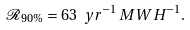Convert formula to latex. <formula><loc_0><loc_0><loc_500><loc_500>\mathcal { R } _ { 9 0 \% } = 6 3 \ y r ^ { - 1 } \, M W H ^ { - 1 } .</formula> 